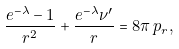<formula> <loc_0><loc_0><loc_500><loc_500>\frac { e ^ { - \lambda } - 1 } { r ^ { 2 } } + \frac { e ^ { - \lambda } \nu ^ { \prime } } { r } = 8 \pi \, p _ { r } ,</formula> 